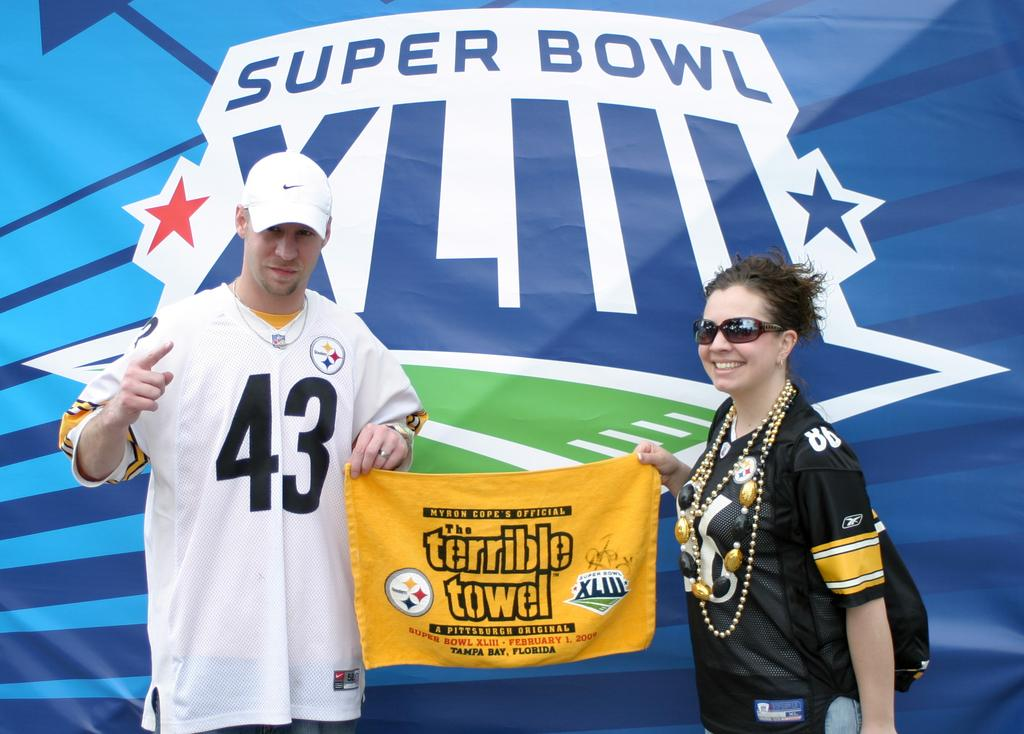Provide a one-sentence caption for the provided image. A man with a white #43 jersey and a woman hold a banner that says "The Terrible Towel" with a banner for Super Bowl XLIII in the background. 